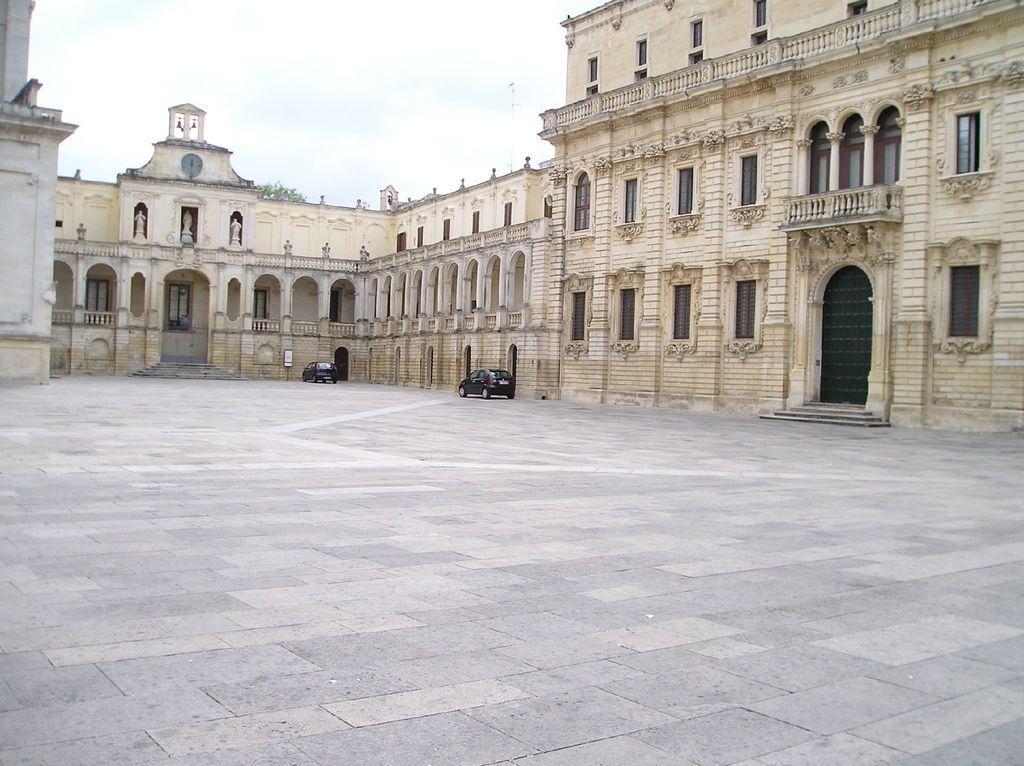Describe this image in one or two sentences. In this image we can see a place which is having multiple entries and may windows. There are two cars in the image. There is a clear sky in the image. 